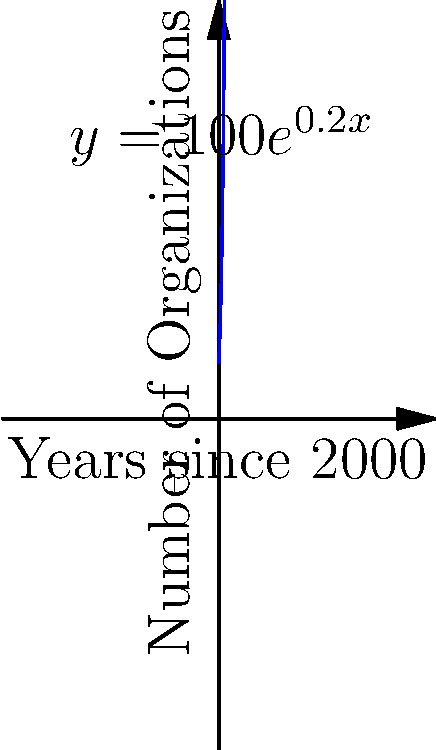The graph shows the exponential growth of female-led environmental organizations since the year 2000. The function $y = 100e^{0.2x}$ models this growth, where $y$ represents the number of organizations and $x$ represents the number of years since 2000. How many female-led environmental organizations are predicted to exist in 2025? To solve this problem, we need to follow these steps:

1. Identify the year we're calculating for: 2025
2. Calculate how many years have passed since 2000: 2025 - 2000 = 25 years
3. Use the given function $y = 100e^{0.2x}$ to calculate the number of organizations
4. Substitute x = 25 into the equation:
   $y = 100e^{0.2(25)}$
5. Calculate:
   $y = 100e^5$
   $y = 100 * (e^5)$
   $y ≈ 100 * 148.4$
   $y ≈ 14,840$

Therefore, the model predicts approximately 14,840 female-led environmental organizations in 2025.
Answer: 14,840 organizations 